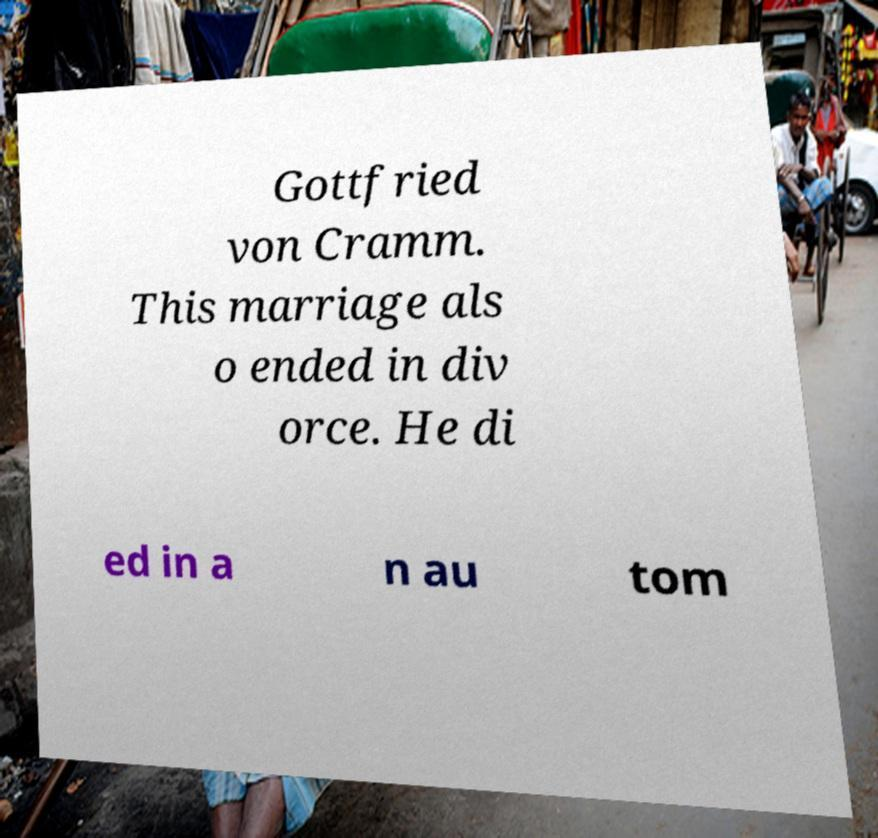Could you extract and type out the text from this image? Gottfried von Cramm. This marriage als o ended in div orce. He di ed in a n au tom 